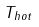<formula> <loc_0><loc_0><loc_500><loc_500>T _ { h o t }</formula> 